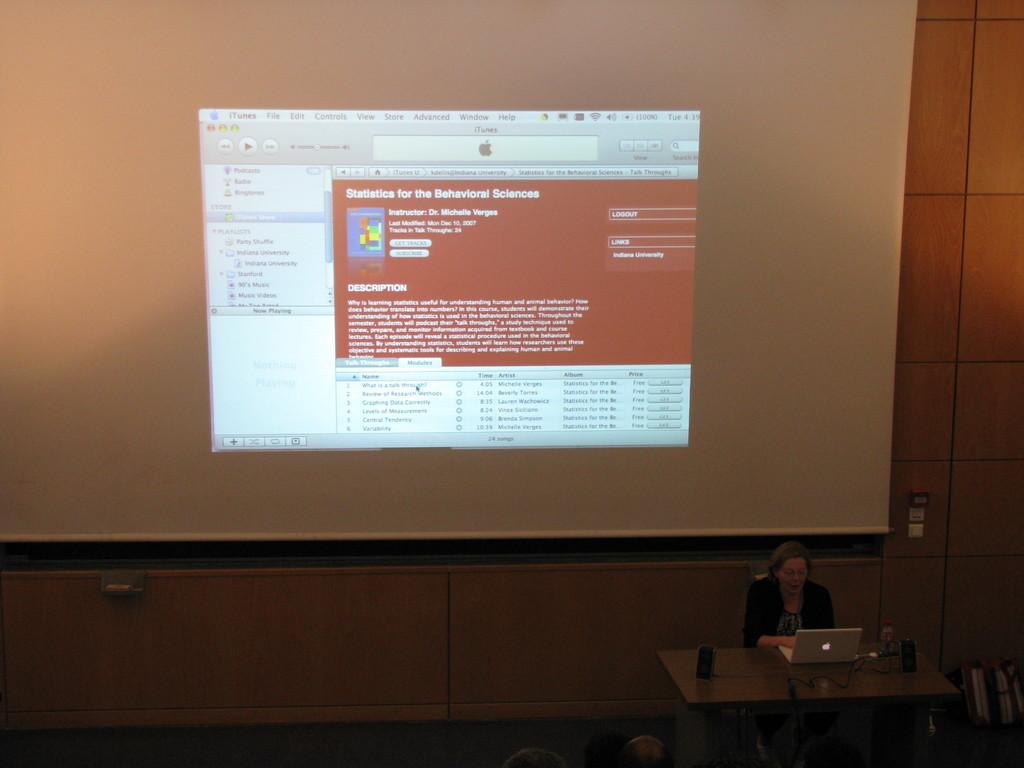<image>
Present a compact description of the photo's key features. A woman is giving a presentation on statistics for behavior sciences. 